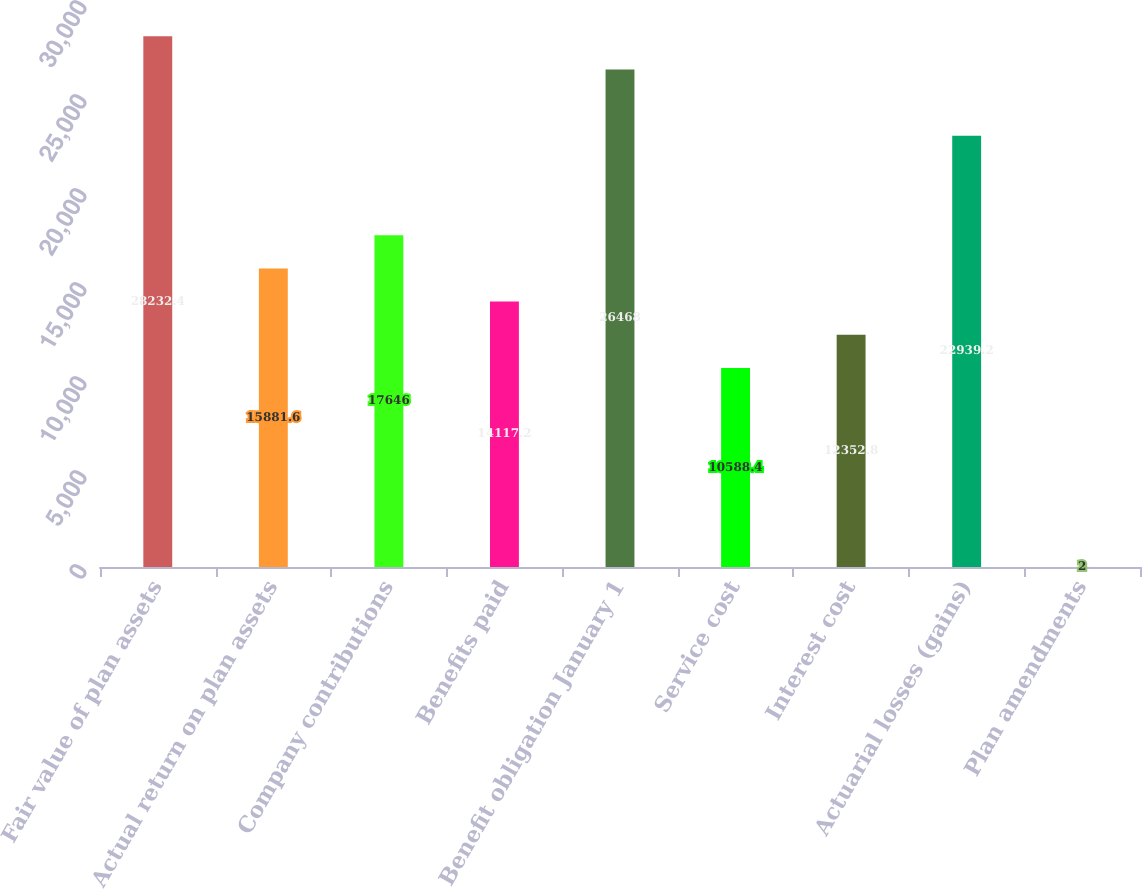Convert chart. <chart><loc_0><loc_0><loc_500><loc_500><bar_chart><fcel>Fair value of plan assets<fcel>Actual return on plan assets<fcel>Company contributions<fcel>Benefits paid<fcel>Benefit obligation January 1<fcel>Service cost<fcel>Interest cost<fcel>Actuarial losses (gains)<fcel>Plan amendments<nl><fcel>28232.4<fcel>15881.6<fcel>17646<fcel>14117.2<fcel>26468<fcel>10588.4<fcel>12352.8<fcel>22939.2<fcel>2<nl></chart> 